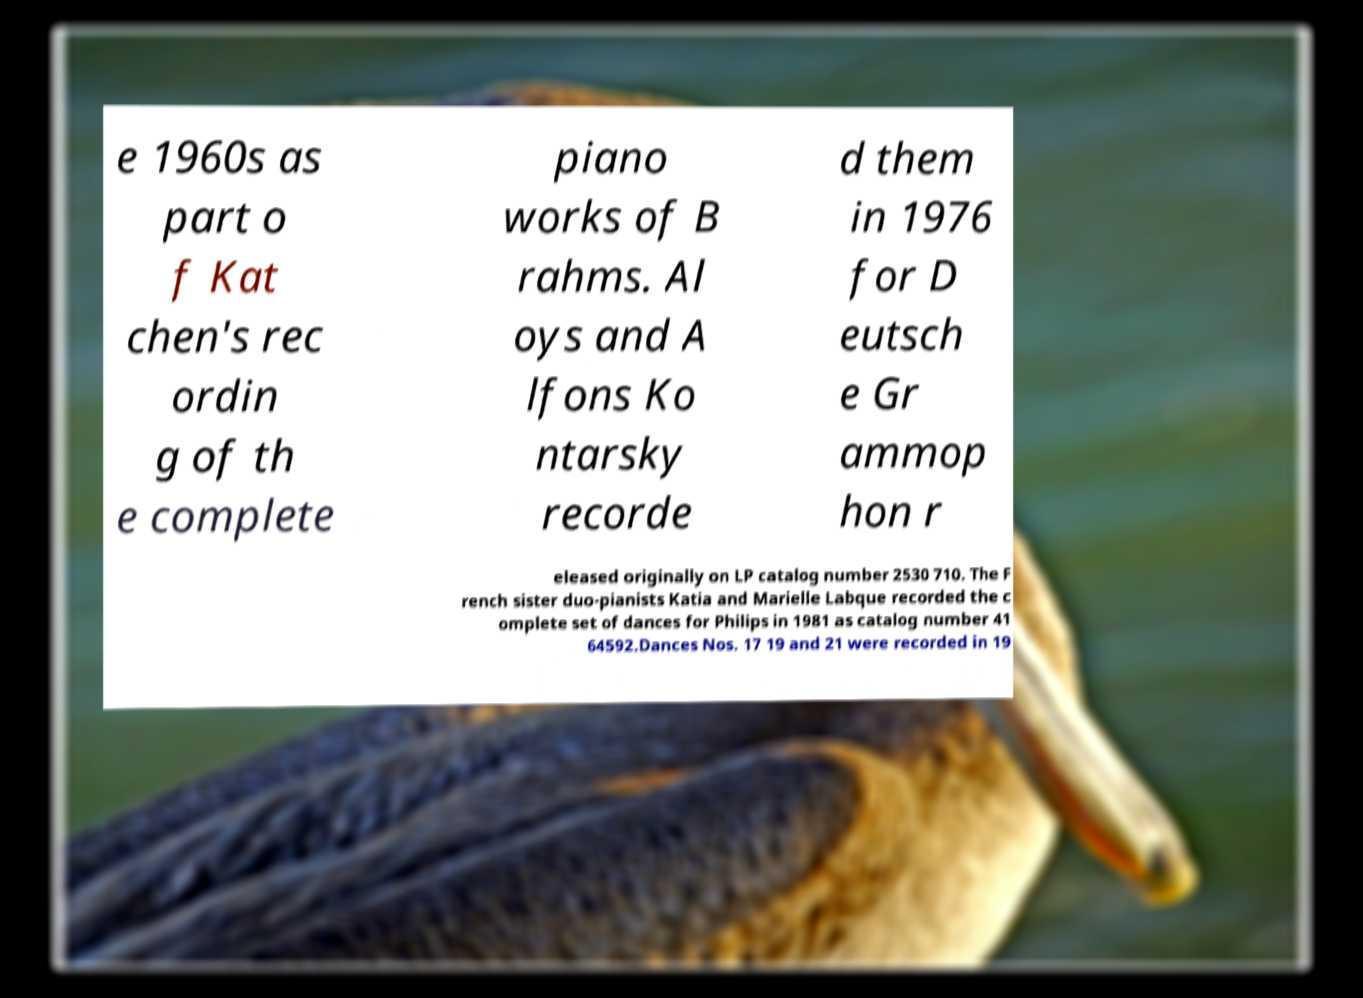What messages or text are displayed in this image? I need them in a readable, typed format. e 1960s as part o f Kat chen's rec ordin g of th e complete piano works of B rahms. Al oys and A lfons Ko ntarsky recorde d them in 1976 for D eutsch e Gr ammop hon r eleased originally on LP catalog number 2530 710. The F rench sister duo-pianists Katia and Marielle Labque recorded the c omplete set of dances for Philips in 1981 as catalog number 41 64592.Dances Nos. 17 19 and 21 were recorded in 19 